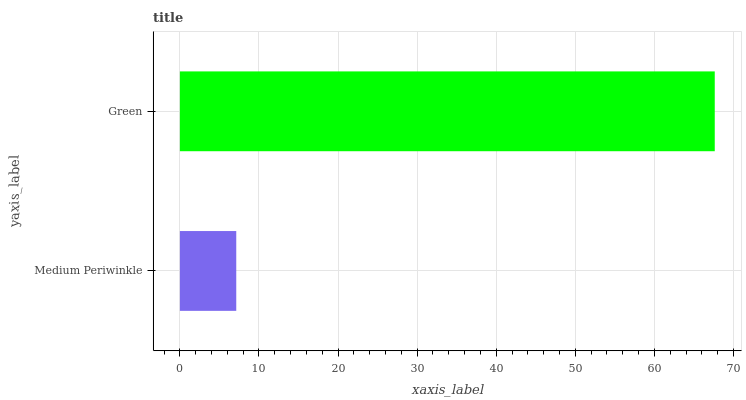Is Medium Periwinkle the minimum?
Answer yes or no. Yes. Is Green the maximum?
Answer yes or no. Yes. Is Green the minimum?
Answer yes or no. No. Is Green greater than Medium Periwinkle?
Answer yes or no. Yes. Is Medium Periwinkle less than Green?
Answer yes or no. Yes. Is Medium Periwinkle greater than Green?
Answer yes or no. No. Is Green less than Medium Periwinkle?
Answer yes or no. No. Is Green the high median?
Answer yes or no. Yes. Is Medium Periwinkle the low median?
Answer yes or no. Yes. Is Medium Periwinkle the high median?
Answer yes or no. No. Is Green the low median?
Answer yes or no. No. 